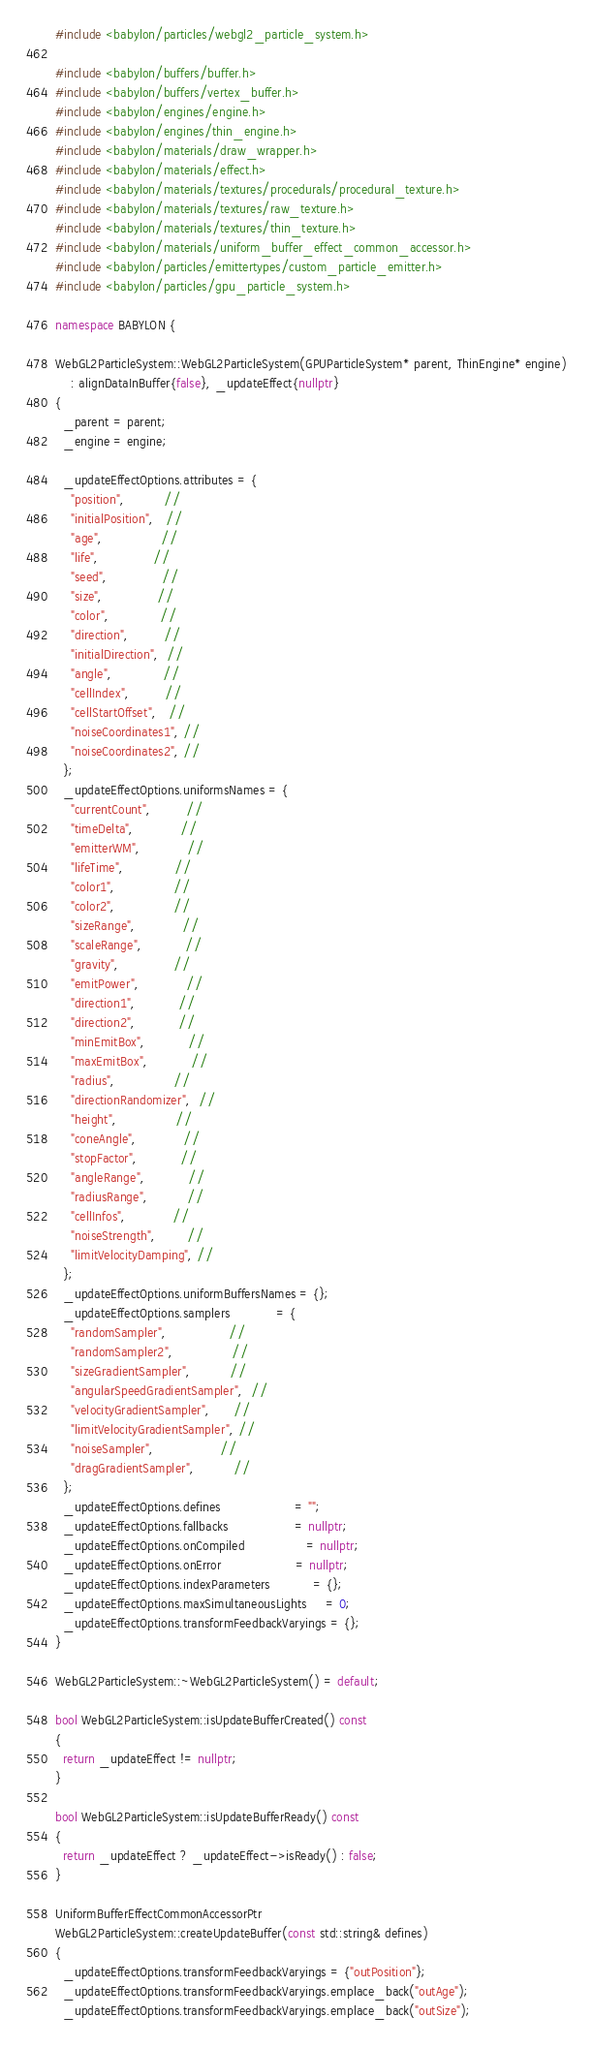Convert code to text. <code><loc_0><loc_0><loc_500><loc_500><_C++_>#include <babylon/particles/webgl2_particle_system.h>

#include <babylon/buffers/buffer.h>
#include <babylon/buffers/vertex_buffer.h>
#include <babylon/engines/engine.h>
#include <babylon/engines/thin_engine.h>
#include <babylon/materials/draw_wrapper.h>
#include <babylon/materials/effect.h>
#include <babylon/materials/textures/procedurals/procedural_texture.h>
#include <babylon/materials/textures/raw_texture.h>
#include <babylon/materials/textures/thin_texture.h>
#include <babylon/materials/uniform_buffer_effect_common_accessor.h>
#include <babylon/particles/emittertypes/custom_particle_emitter.h>
#include <babylon/particles/gpu_particle_system.h>

namespace BABYLON {

WebGL2ParticleSystem::WebGL2ParticleSystem(GPUParticleSystem* parent, ThinEngine* engine)
    : alignDataInBuffer{false}, _updateEffect{nullptr}
{
  _parent = parent;
  _engine = engine;

  _updateEffectOptions.attributes = {
    "position",          //
    "initialPosition",   //
    "age",               //
    "life",              //
    "seed",              //
    "size",              //
    "color",             //
    "direction",         //
    "initialDirection",  //
    "angle",             //
    "cellIndex",         //
    "cellStartOffset",   //
    "noiseCoordinates1", //
    "noiseCoordinates2", //
  };
  _updateEffectOptions.uniformsNames = {
    "currentCount",         //
    "timeDelta",            //
    "emitterWM",            //
    "lifeTime",             //
    "color1",               //
    "color2",               //
    "sizeRange",            //
    "scaleRange",           //
    "gravity",              //
    "emitPower",            //
    "direction1",           //
    "direction2",           //
    "minEmitBox",           //
    "maxEmitBox",           //
    "radius",               //
    "directionRandomizer",  //
    "height",               //
    "coneAngle",            //
    "stopFactor",           //
    "angleRange",           //
    "radiusRange",          //
    "cellInfos",            //
    "noiseStrength",        //
    "limitVelocityDamping", //
  };
  _updateEffectOptions.uniformBuffersNames = {};
  _updateEffectOptions.samplers            = {
    "randomSampler",                //
    "randomSampler2",               //
    "sizeGradientSampler",          //
    "angularSpeedGradientSampler",  //
    "velocityGradientSampler",      //
    "limitVelocityGradientSampler", //
    "noiseSampler",                 //
    "dragGradientSampler",          //
  };
  _updateEffectOptions.defines                   = "";
  _updateEffectOptions.fallbacks                 = nullptr;
  _updateEffectOptions.onCompiled                = nullptr;
  _updateEffectOptions.onError                   = nullptr;
  _updateEffectOptions.indexParameters           = {};
  _updateEffectOptions.maxSimultaneousLights     = 0;
  _updateEffectOptions.transformFeedbackVaryings = {};
}

WebGL2ParticleSystem::~WebGL2ParticleSystem() = default;

bool WebGL2ParticleSystem::isUpdateBufferCreated() const
{
  return _updateEffect != nullptr;
}

bool WebGL2ParticleSystem::isUpdateBufferReady() const
{
  return _updateEffect ? _updateEffect->isReady() : false;
}

UniformBufferEffectCommonAccessorPtr
WebGL2ParticleSystem::createUpdateBuffer(const std::string& defines)
{
  _updateEffectOptions.transformFeedbackVaryings = {"outPosition"};
  _updateEffectOptions.transformFeedbackVaryings.emplace_back("outAge");
  _updateEffectOptions.transformFeedbackVaryings.emplace_back("outSize");</code> 